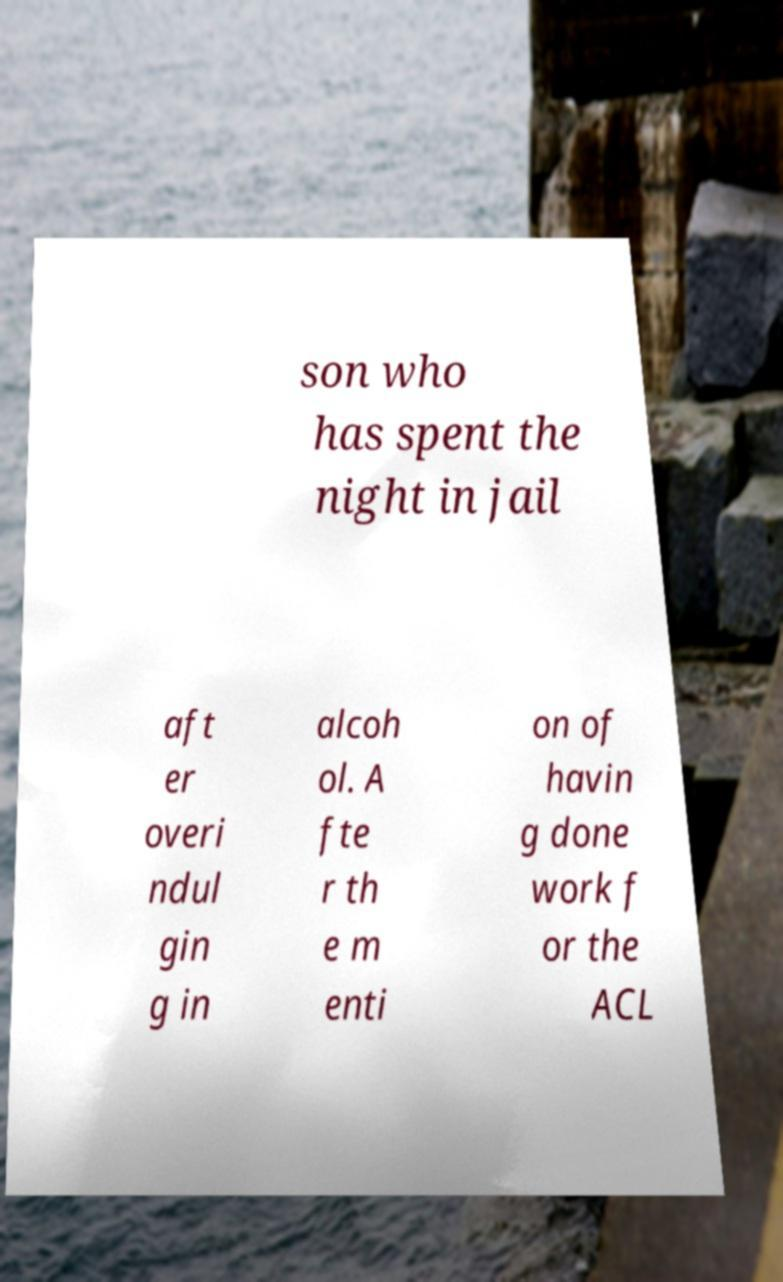Please identify and transcribe the text found in this image. son who has spent the night in jail aft er overi ndul gin g in alcoh ol. A fte r th e m enti on of havin g done work f or the ACL 